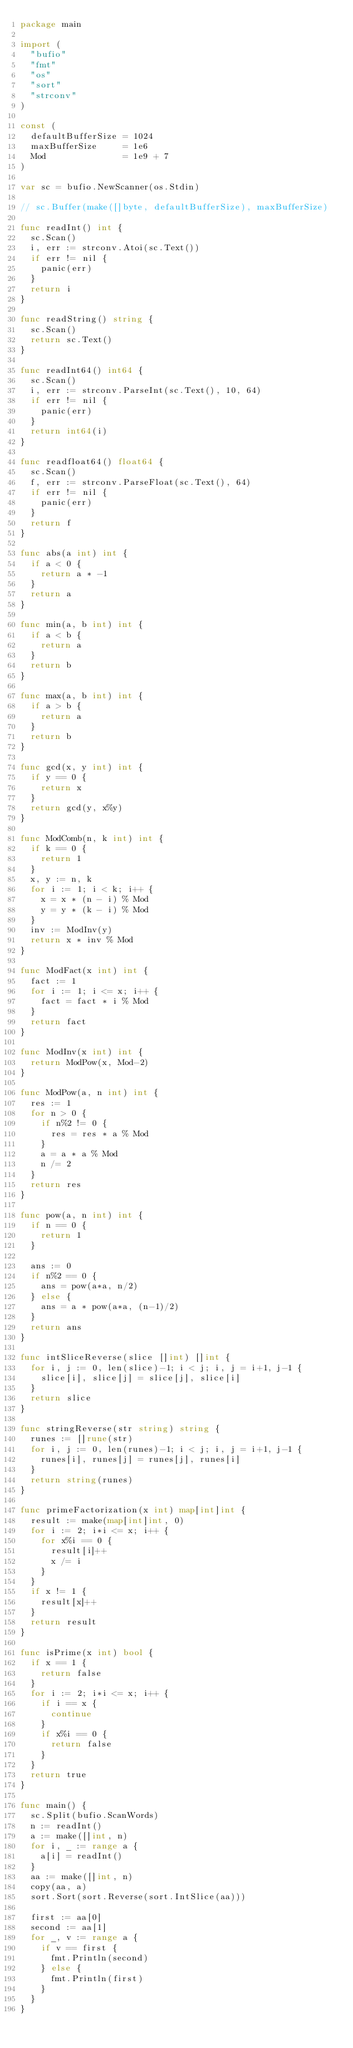<code> <loc_0><loc_0><loc_500><loc_500><_Go_>package main

import (
	"bufio"
	"fmt"
	"os"
	"sort"
	"strconv"
)

const (
	defaultBufferSize = 1024
	maxBufferSize     = 1e6
	Mod               = 1e9 + 7
)

var sc = bufio.NewScanner(os.Stdin)

// sc.Buffer(make([]byte, defaultBufferSize), maxBufferSize)

func readInt() int {
	sc.Scan()
	i, err := strconv.Atoi(sc.Text())
	if err != nil {
		panic(err)
	}
	return i
}

func readString() string {
	sc.Scan()
	return sc.Text()
}

func readInt64() int64 {
	sc.Scan()
	i, err := strconv.ParseInt(sc.Text(), 10, 64)
	if err != nil {
		panic(err)
	}
	return int64(i)
}

func readfloat64() float64 {
	sc.Scan()
	f, err := strconv.ParseFloat(sc.Text(), 64)
	if err != nil {
		panic(err)
	}
	return f
}

func abs(a int) int {
	if a < 0 {
		return a * -1
	}
	return a
}

func min(a, b int) int {
	if a < b {
		return a
	}
	return b
}

func max(a, b int) int {
	if a > b {
		return a
	}
	return b
}

func gcd(x, y int) int {
	if y == 0 {
		return x
	}
	return gcd(y, x%y)
}

func ModComb(n, k int) int {
	if k == 0 {
		return 1
	}
	x, y := n, k
	for i := 1; i < k; i++ {
		x = x * (n - i) % Mod
		y = y * (k - i) % Mod
	}
	inv := ModInv(y)
	return x * inv % Mod
}

func ModFact(x int) int {
	fact := 1
	for i := 1; i <= x; i++ {
		fact = fact * i % Mod
	}
	return fact
}

func ModInv(x int) int {
	return ModPow(x, Mod-2)
}

func ModPow(a, n int) int {
	res := 1
	for n > 0 {
		if n%2 != 0 {
			res = res * a % Mod
		}
		a = a * a % Mod
		n /= 2
	}
	return res
}

func pow(a, n int) int {
	if n == 0 {
		return 1
	}

	ans := 0
	if n%2 == 0 {
		ans = pow(a*a, n/2)
	} else {
		ans = a * pow(a*a, (n-1)/2)
	}
	return ans
}

func intSliceReverse(slice []int) []int {
	for i, j := 0, len(slice)-1; i < j; i, j = i+1, j-1 {
		slice[i], slice[j] = slice[j], slice[i]
	}
	return slice
}

func stringReverse(str string) string {
	runes := []rune(str)
	for i, j := 0, len(runes)-1; i < j; i, j = i+1, j-1 {
		runes[i], runes[j] = runes[j], runes[i]
	}
	return string(runes)
}

func primeFactorization(x int) map[int]int {
	result := make(map[int]int, 0)
	for i := 2; i*i <= x; i++ {
		for x%i == 0 {
			result[i]++
			x /= i
		}
	}
	if x != 1 {
		result[x]++
	}
	return result
}

func isPrime(x int) bool {
	if x == 1 {
		return false
	}
	for i := 2; i*i <= x; i++ {
		if i == x {
			continue
		}
		if x%i == 0 {
			return false
		}
	}
	return true
}

func main() {
	sc.Split(bufio.ScanWords)
	n := readInt()
	a := make([]int, n)
	for i, _ := range a {
		a[i] = readInt()
	}
	aa := make([]int, n)
	copy(aa, a)
	sort.Sort(sort.Reverse(sort.IntSlice(aa)))

	first := aa[0]
	second := aa[1]
	for _, v := range a {
		if v == first {
			fmt.Println(second)
		} else {
			fmt.Println(first)
		}
	}
}
</code> 